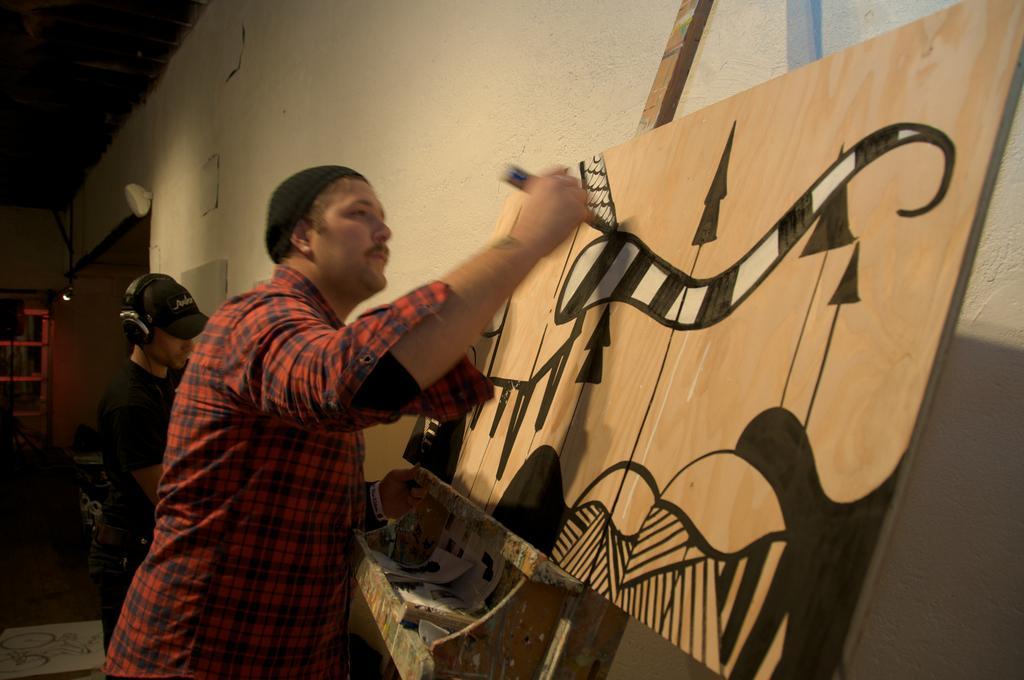In one or two sentences, can you explain what this image depicts? On the left side, there is a person in a shirt, holding an object with a hand and painting on a wooden board. Beside him, there is another person wearing headset and standing. In the background, there is a light, a cupboard and there is a wall. 